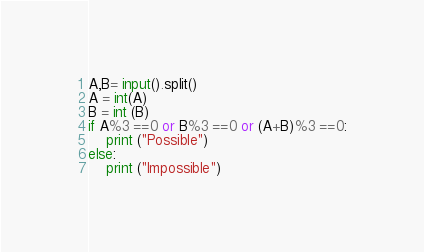<code> <loc_0><loc_0><loc_500><loc_500><_Python_>A,B= input().split()
A = int(A)
B = int (B)
if A%3 ==0 or B%3 ==0 or (A+B)%3 ==0:
    print ("Possible")
else:
    print ("Impossible")</code> 